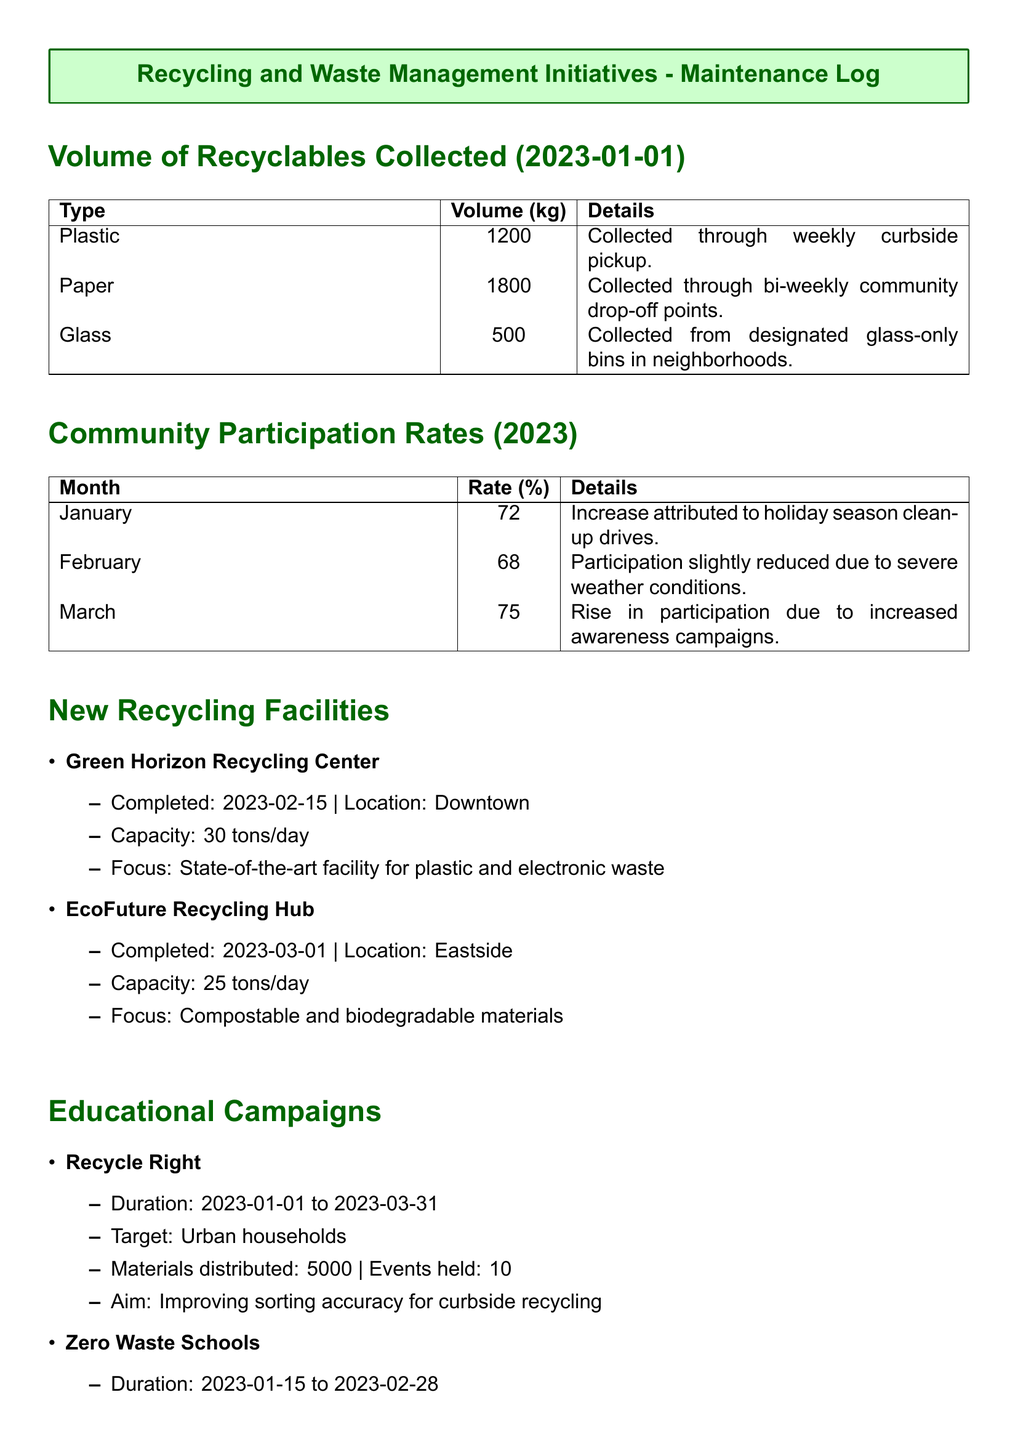what volume of plastic recyclables was collected? The volume of plastic recyclables is specified in the document under the section "Volume of Recyclables Collected."
Answer: 1200 kg what was the community participation rate in March? The community participation rate for March is mentioned in the "Community Participation Rates" section of the document.
Answer: 75% when was the Green Horizon Recycling Center completed? The completion date for the Green Horizon Recycling Center is found in the section describing New Recycling Facilities.
Answer: 2023-02-15 how many events were held for the Recycle Right campaign? The number of events for the Recycle Right campaign is given in the section detailing Educational Campaigns.
Answer: 10 what is the capacity of the EcoFuture Recycling Hub? The capacity of the EcoFuture Recycling Hub is included in the description of the facility within the New Recycling Facilities section.
Answer: 25 tons/day which educational campaign targeted school children? The educational campaign that specifically targeted school children is found in the Educational Campaigns section.
Answer: Zero Waste Schools what type of materials did the Green Horizon Recycling Center focus on? The focus of the Green Horizon Recycling Center is outlined in the details of the New Recycling Facilities section.
Answer: Plastic and electronic waste what was the participation rate in February? The participation rate for February is stated in the "Community Participation Rates" section.
Answer: 68% 